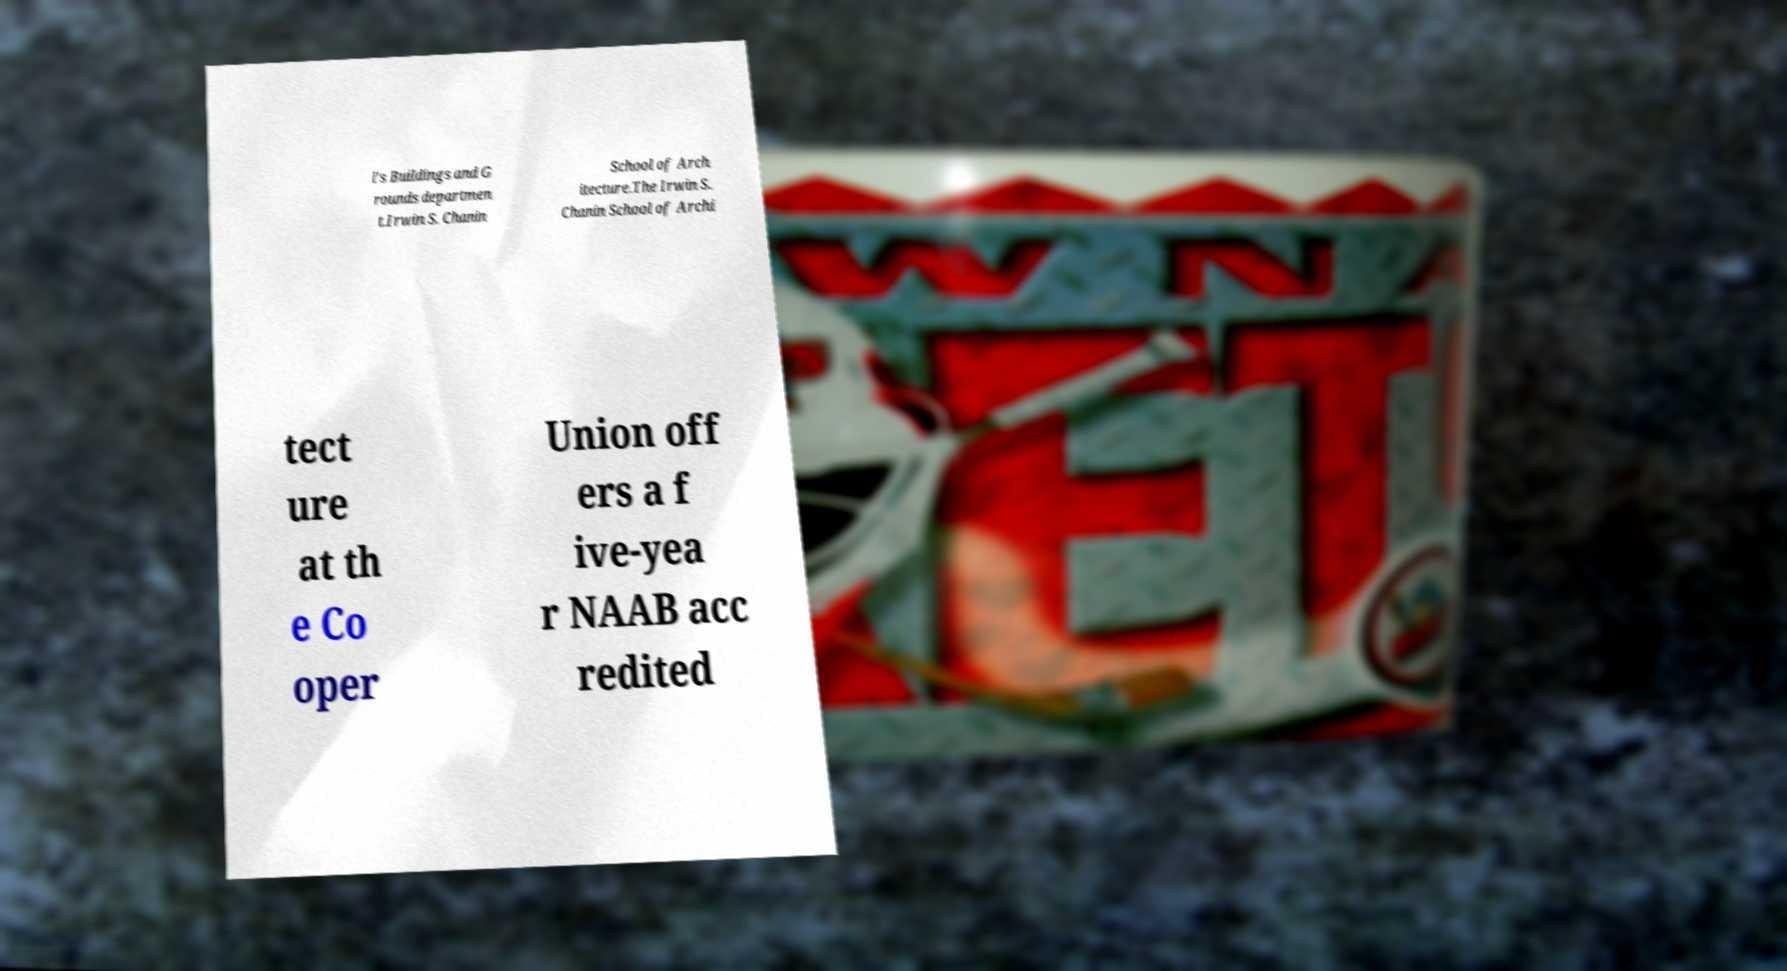Please read and relay the text visible in this image. What does it say? l's Buildings and G rounds departmen t.Irwin S. Chanin School of Arch itecture.The Irwin S. Chanin School of Archi tect ure at th e Co oper Union off ers a f ive-yea r NAAB acc redited 